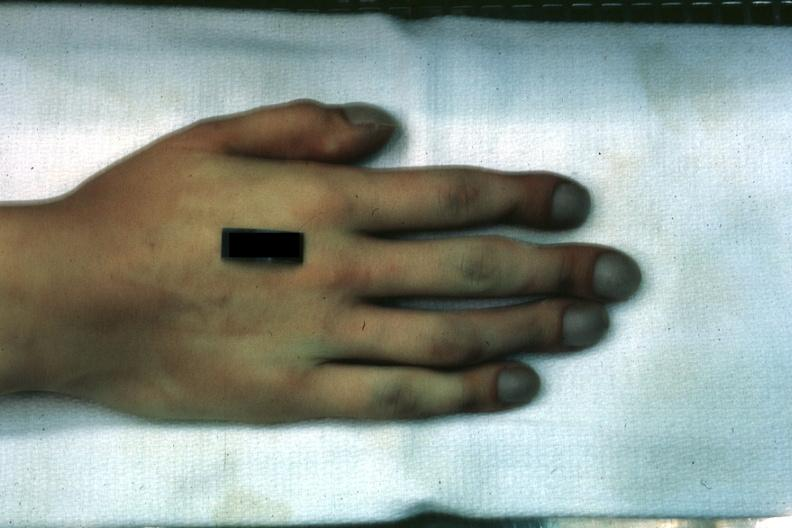does this image show case of transposition of great vessels with vsd age 22 yrs?
Answer the question using a single word or phrase. Yes 